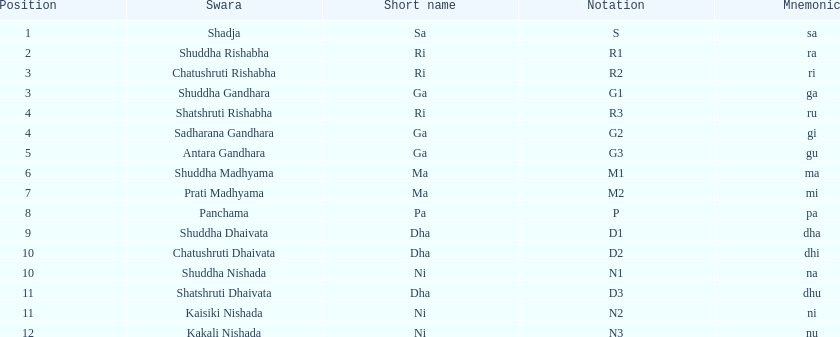List each pair of swaras that share the same position. Chatushruti Rishabha, Shuddha Gandhara, Shatshruti Rishabha, Sadharana Gandhara, Chatushruti Dhaivata, Shuddha Nishada, Shatshruti Dhaivata, Kaisiki Nishada. 